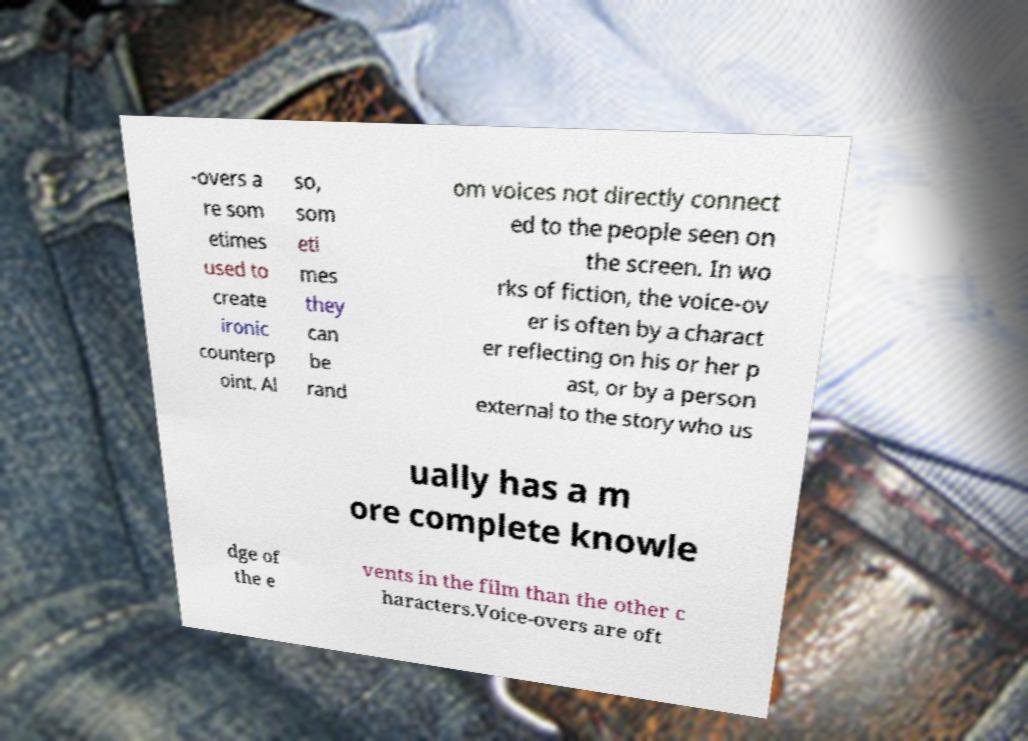I need the written content from this picture converted into text. Can you do that? -overs a re som etimes used to create ironic counterp oint. Al so, som eti mes they can be rand om voices not directly connect ed to the people seen on the screen. In wo rks of fiction, the voice-ov er is often by a charact er reflecting on his or her p ast, or by a person external to the story who us ually has a m ore complete knowle dge of the e vents in the film than the other c haracters.Voice-overs are oft 